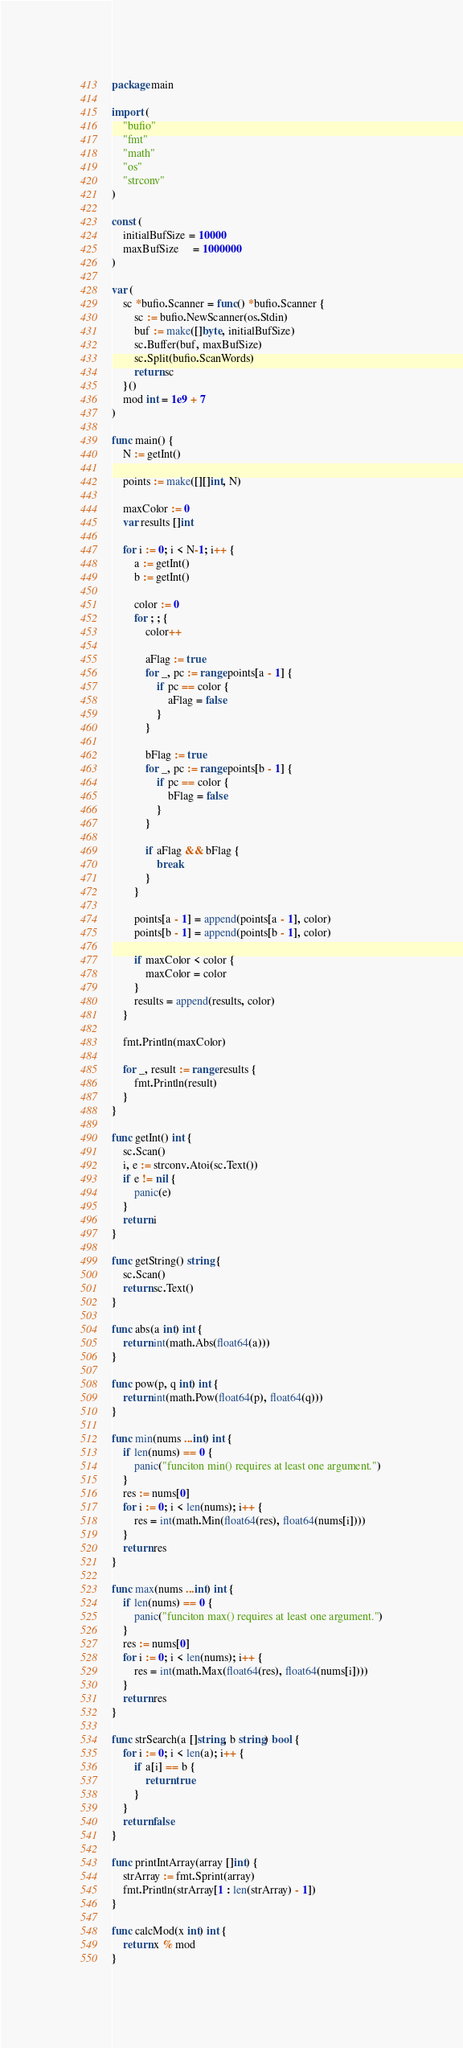Convert code to text. <code><loc_0><loc_0><loc_500><loc_500><_Go_>package main

import (
	"bufio"
	"fmt"
	"math"
	"os"
	"strconv"
)

const (
	initialBufSize = 10000
	maxBufSize     = 1000000
)

var (
	sc *bufio.Scanner = func() *bufio.Scanner {
		sc := bufio.NewScanner(os.Stdin)
		buf := make([]byte, initialBufSize)
		sc.Buffer(buf, maxBufSize)
		sc.Split(bufio.ScanWords)
		return sc
	}()
	mod int = 1e9 + 7
)

func main() {
	N := getInt()

	points := make([][]int, N)

	maxColor := 0
	var results []int

	for i := 0; i < N-1; i++ {
		a := getInt()
		b := getInt()

		color := 0
		for ; ; {
			color++

			aFlag := true
			for _, pc := range points[a - 1] {
				if pc == color {
					aFlag = false
				}
			}

			bFlag := true
			for _, pc := range points[b - 1] {
				if pc == color {
					bFlag = false
				}
			}

			if aFlag && bFlag {
				break
			}
		}

		points[a - 1] = append(points[a - 1], color)
		points[b - 1] = append(points[b - 1], color)

		if maxColor < color {
			maxColor = color
		}
		results = append(results, color)
	}

	fmt.Println(maxColor)

	for _, result := range results {
		fmt.Println(result)
	}
}

func getInt() int {
	sc.Scan()
	i, e := strconv.Atoi(sc.Text())
	if e != nil {
		panic(e)
	}
	return i
}

func getString() string {
	sc.Scan()
	return sc.Text()
}

func abs(a int) int {
	return int(math.Abs(float64(a)))
}

func pow(p, q int) int {
	return int(math.Pow(float64(p), float64(q)))
}

func min(nums ...int) int {
	if len(nums) == 0 {
		panic("funciton min() requires at least one argument.")
	}
	res := nums[0]
	for i := 0; i < len(nums); i++ {
		res = int(math.Min(float64(res), float64(nums[i])))
	}
	return res
}

func max(nums ...int) int {
	if len(nums) == 0 {
		panic("funciton max() requires at least one argument.")
	}
	res := nums[0]
	for i := 0; i < len(nums); i++ {
		res = int(math.Max(float64(res), float64(nums[i])))
	}
	return res
}

func strSearch(a []string, b string) bool {
	for i := 0; i < len(a); i++ {
		if a[i] == b {
			return true
		}
	}
	return false
}

func printIntArray(array []int) {
	strArray := fmt.Sprint(array)
	fmt.Println(strArray[1 : len(strArray) - 1])
}

func calcMod(x int) int {
	return x % mod
}
</code> 